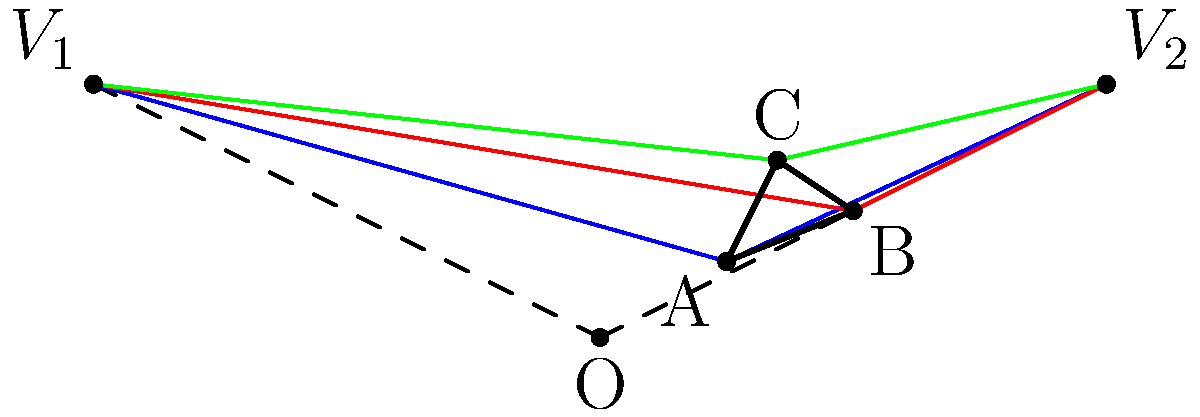In a street art-inspired perspective drawing, you've created a triangle ABC with two vanishing points $V_1$ and $V_2$. If the horizon line is parallel to the base of your canvas and point O is directly below the triangle, which side of the triangle appears to be parallel to the horizon line in this two-point perspective? To determine which side of the triangle appears parallel to the horizon line in two-point perspective, we need to analyze the lines connecting each vertex to the vanishing points:

1. In two-point perspective, lines that are parallel to the horizon in reality will converge at a vanishing point in the drawing.
2. Lines that are perpendicular to the horizon in reality will remain vertical in the drawing.
3. Lines that are parallel to the horizon in the drawing will not converge at either vanishing point.

Let's examine each side of the triangle:

1. Side AB: Lines from both A and B converge to both vanishing points, indicating that AB is not parallel to the horizon.
2. Side BC: Lines from both B and C converge to both vanishing points, indicating that BC is not parallel to the horizon.
3. Side AC: Lines from both A and C converge to both vanishing points, indicating that AC is not parallel to the horizon.

Since all sides of the triangle have lines converging to both vanishing points, none of the sides appear parallel to the horizon line in this two-point perspective drawing.
Answer: None of the sides 